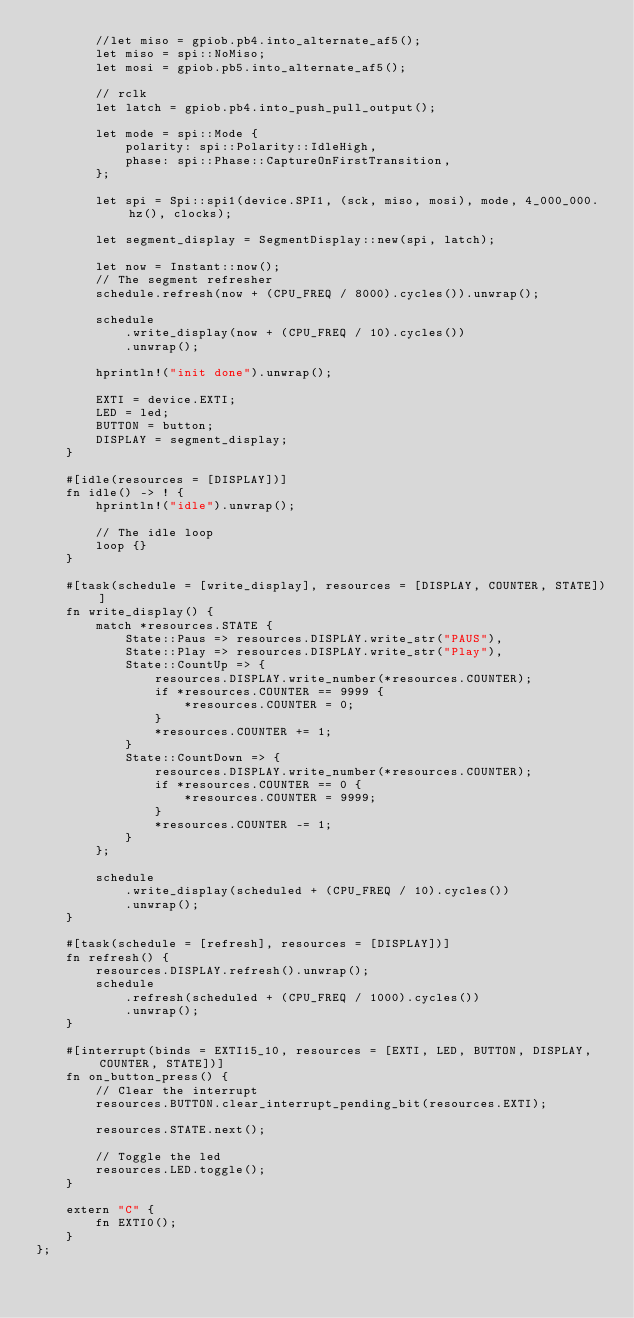<code> <loc_0><loc_0><loc_500><loc_500><_Rust_>        //let miso = gpiob.pb4.into_alternate_af5();
        let miso = spi::NoMiso;
        let mosi = gpiob.pb5.into_alternate_af5();

        // rclk
        let latch = gpiob.pb4.into_push_pull_output();

        let mode = spi::Mode {
            polarity: spi::Polarity::IdleHigh,
            phase: spi::Phase::CaptureOnFirstTransition,
        };

        let spi = Spi::spi1(device.SPI1, (sck, miso, mosi), mode, 4_000_000.hz(), clocks);

        let segment_display = SegmentDisplay::new(spi, latch);

        let now = Instant::now();
        // The segment refresher
        schedule.refresh(now + (CPU_FREQ / 8000).cycles()).unwrap();

        schedule
            .write_display(now + (CPU_FREQ / 10).cycles())
            .unwrap();

        hprintln!("init done").unwrap();

        EXTI = device.EXTI;
        LED = led;
        BUTTON = button;
        DISPLAY = segment_display;
    }

    #[idle(resources = [DISPLAY])]
    fn idle() -> ! {
        hprintln!("idle").unwrap();

        // The idle loop
        loop {}
    }

    #[task(schedule = [write_display], resources = [DISPLAY, COUNTER, STATE])]
    fn write_display() {
        match *resources.STATE {
            State::Paus => resources.DISPLAY.write_str("PAUS"),
            State::Play => resources.DISPLAY.write_str("Play"),
            State::CountUp => {
                resources.DISPLAY.write_number(*resources.COUNTER);
                if *resources.COUNTER == 9999 {
                    *resources.COUNTER = 0;
                }
                *resources.COUNTER += 1;
            }
            State::CountDown => {
                resources.DISPLAY.write_number(*resources.COUNTER);
                if *resources.COUNTER == 0 {
                    *resources.COUNTER = 9999;
                }
                *resources.COUNTER -= 1;
            }
        };

        schedule
            .write_display(scheduled + (CPU_FREQ / 10).cycles())
            .unwrap();
    }

    #[task(schedule = [refresh], resources = [DISPLAY])]
    fn refresh() {
        resources.DISPLAY.refresh().unwrap();
        schedule
            .refresh(scheduled + (CPU_FREQ / 1000).cycles())
            .unwrap();
    }

    #[interrupt(binds = EXTI15_10, resources = [EXTI, LED, BUTTON, DISPLAY, COUNTER, STATE])]
    fn on_button_press() {
        // Clear the interrupt
        resources.BUTTON.clear_interrupt_pending_bit(resources.EXTI);

        resources.STATE.next();

        // Toggle the led
        resources.LED.toggle();
    }

    extern "C" {
        fn EXTI0();
    }
};
</code> 